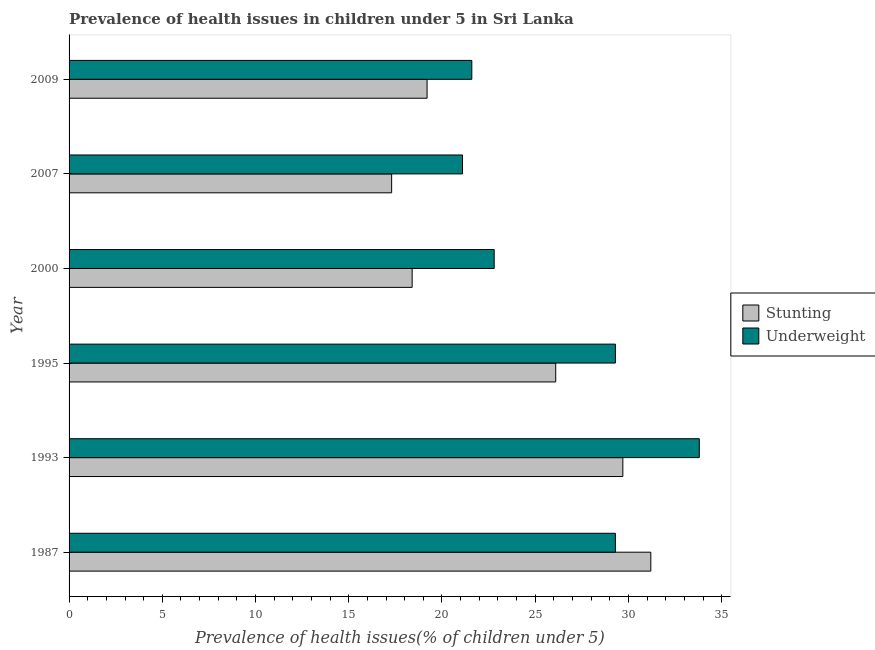How many different coloured bars are there?
Give a very brief answer. 2. How many groups of bars are there?
Ensure brevity in your answer.  6. Are the number of bars on each tick of the Y-axis equal?
Give a very brief answer. Yes. How many bars are there on the 1st tick from the bottom?
Offer a very short reply. 2. What is the label of the 3rd group of bars from the top?
Provide a succinct answer. 2000. In how many cases, is the number of bars for a given year not equal to the number of legend labels?
Make the answer very short. 0. What is the percentage of stunted children in 1993?
Offer a very short reply. 29.7. Across all years, what is the maximum percentage of stunted children?
Keep it short and to the point. 31.2. Across all years, what is the minimum percentage of underweight children?
Give a very brief answer. 21.1. What is the total percentage of stunted children in the graph?
Your answer should be very brief. 141.9. What is the difference between the percentage of underweight children in 2009 and the percentage of stunted children in 1987?
Offer a very short reply. -9.6. What is the average percentage of underweight children per year?
Offer a terse response. 26.32. What is the ratio of the percentage of stunted children in 1995 to that in 2009?
Give a very brief answer. 1.36. What is the difference between the highest and the second highest percentage of underweight children?
Provide a short and direct response. 4.5. What is the difference between the highest and the lowest percentage of underweight children?
Keep it short and to the point. 12.7. What does the 1st bar from the top in 2000 represents?
Your answer should be very brief. Underweight. What does the 1st bar from the bottom in 1987 represents?
Provide a short and direct response. Stunting. How many bars are there?
Ensure brevity in your answer.  12. What is the difference between two consecutive major ticks on the X-axis?
Offer a very short reply. 5. Are the values on the major ticks of X-axis written in scientific E-notation?
Your answer should be very brief. No. Does the graph contain grids?
Provide a short and direct response. No. What is the title of the graph?
Your answer should be very brief. Prevalence of health issues in children under 5 in Sri Lanka. Does "Number of arrivals" appear as one of the legend labels in the graph?
Provide a short and direct response. No. What is the label or title of the X-axis?
Give a very brief answer. Prevalence of health issues(% of children under 5). What is the Prevalence of health issues(% of children under 5) of Stunting in 1987?
Keep it short and to the point. 31.2. What is the Prevalence of health issues(% of children under 5) of Underweight in 1987?
Provide a short and direct response. 29.3. What is the Prevalence of health issues(% of children under 5) in Stunting in 1993?
Your answer should be very brief. 29.7. What is the Prevalence of health issues(% of children under 5) of Underweight in 1993?
Provide a short and direct response. 33.8. What is the Prevalence of health issues(% of children under 5) in Stunting in 1995?
Your response must be concise. 26.1. What is the Prevalence of health issues(% of children under 5) of Underweight in 1995?
Your answer should be compact. 29.3. What is the Prevalence of health issues(% of children under 5) of Stunting in 2000?
Make the answer very short. 18.4. What is the Prevalence of health issues(% of children under 5) in Underweight in 2000?
Your answer should be compact. 22.8. What is the Prevalence of health issues(% of children under 5) in Stunting in 2007?
Keep it short and to the point. 17.3. What is the Prevalence of health issues(% of children under 5) in Underweight in 2007?
Your response must be concise. 21.1. What is the Prevalence of health issues(% of children under 5) in Stunting in 2009?
Ensure brevity in your answer.  19.2. What is the Prevalence of health issues(% of children under 5) of Underweight in 2009?
Keep it short and to the point. 21.6. Across all years, what is the maximum Prevalence of health issues(% of children under 5) of Stunting?
Keep it short and to the point. 31.2. Across all years, what is the maximum Prevalence of health issues(% of children under 5) of Underweight?
Provide a short and direct response. 33.8. Across all years, what is the minimum Prevalence of health issues(% of children under 5) in Stunting?
Provide a short and direct response. 17.3. Across all years, what is the minimum Prevalence of health issues(% of children under 5) in Underweight?
Offer a terse response. 21.1. What is the total Prevalence of health issues(% of children under 5) of Stunting in the graph?
Make the answer very short. 141.9. What is the total Prevalence of health issues(% of children under 5) in Underweight in the graph?
Offer a very short reply. 157.9. What is the difference between the Prevalence of health issues(% of children under 5) in Stunting in 1987 and that in 1995?
Keep it short and to the point. 5.1. What is the difference between the Prevalence of health issues(% of children under 5) in Stunting in 1987 and that in 2000?
Keep it short and to the point. 12.8. What is the difference between the Prevalence of health issues(% of children under 5) in Underweight in 1987 and that in 2000?
Make the answer very short. 6.5. What is the difference between the Prevalence of health issues(% of children under 5) of Underweight in 1987 and that in 2007?
Your answer should be compact. 8.2. What is the difference between the Prevalence of health issues(% of children under 5) in Stunting in 1987 and that in 2009?
Your answer should be compact. 12. What is the difference between the Prevalence of health issues(% of children under 5) in Underweight in 1987 and that in 2009?
Your answer should be compact. 7.7. What is the difference between the Prevalence of health issues(% of children under 5) of Stunting in 1993 and that in 2000?
Provide a short and direct response. 11.3. What is the difference between the Prevalence of health issues(% of children under 5) of Stunting in 1993 and that in 2009?
Give a very brief answer. 10.5. What is the difference between the Prevalence of health issues(% of children under 5) of Underweight in 1993 and that in 2009?
Provide a succinct answer. 12.2. What is the difference between the Prevalence of health issues(% of children under 5) of Stunting in 1995 and that in 2000?
Your answer should be very brief. 7.7. What is the difference between the Prevalence of health issues(% of children under 5) in Underweight in 1995 and that in 2000?
Give a very brief answer. 6.5. What is the difference between the Prevalence of health issues(% of children under 5) of Underweight in 1995 and that in 2007?
Offer a terse response. 8.2. What is the difference between the Prevalence of health issues(% of children under 5) in Stunting in 1995 and that in 2009?
Your answer should be very brief. 6.9. What is the difference between the Prevalence of health issues(% of children under 5) in Underweight in 1995 and that in 2009?
Provide a succinct answer. 7.7. What is the difference between the Prevalence of health issues(% of children under 5) in Stunting in 2007 and that in 2009?
Offer a very short reply. -1.9. What is the difference between the Prevalence of health issues(% of children under 5) of Stunting in 1987 and the Prevalence of health issues(% of children under 5) of Underweight in 2007?
Your answer should be compact. 10.1. What is the difference between the Prevalence of health issues(% of children under 5) of Stunting in 1993 and the Prevalence of health issues(% of children under 5) of Underweight in 2000?
Ensure brevity in your answer.  6.9. What is the difference between the Prevalence of health issues(% of children under 5) in Stunting in 1993 and the Prevalence of health issues(% of children under 5) in Underweight in 2007?
Ensure brevity in your answer.  8.6. What is the difference between the Prevalence of health issues(% of children under 5) in Stunting in 1995 and the Prevalence of health issues(% of children under 5) in Underweight in 2000?
Ensure brevity in your answer.  3.3. What is the difference between the Prevalence of health issues(% of children under 5) of Stunting in 1995 and the Prevalence of health issues(% of children under 5) of Underweight in 2007?
Offer a terse response. 5. What is the difference between the Prevalence of health issues(% of children under 5) of Stunting in 2000 and the Prevalence of health issues(% of children under 5) of Underweight in 2007?
Provide a short and direct response. -2.7. What is the difference between the Prevalence of health issues(% of children under 5) of Stunting in 2007 and the Prevalence of health issues(% of children under 5) of Underweight in 2009?
Your response must be concise. -4.3. What is the average Prevalence of health issues(% of children under 5) of Stunting per year?
Offer a very short reply. 23.65. What is the average Prevalence of health issues(% of children under 5) of Underweight per year?
Provide a succinct answer. 26.32. In the year 1993, what is the difference between the Prevalence of health issues(% of children under 5) in Stunting and Prevalence of health issues(% of children under 5) in Underweight?
Provide a short and direct response. -4.1. In the year 1995, what is the difference between the Prevalence of health issues(% of children under 5) of Stunting and Prevalence of health issues(% of children under 5) of Underweight?
Keep it short and to the point. -3.2. In the year 2007, what is the difference between the Prevalence of health issues(% of children under 5) in Stunting and Prevalence of health issues(% of children under 5) in Underweight?
Ensure brevity in your answer.  -3.8. What is the ratio of the Prevalence of health issues(% of children under 5) of Stunting in 1987 to that in 1993?
Your answer should be very brief. 1.05. What is the ratio of the Prevalence of health issues(% of children under 5) in Underweight in 1987 to that in 1993?
Give a very brief answer. 0.87. What is the ratio of the Prevalence of health issues(% of children under 5) of Stunting in 1987 to that in 1995?
Your response must be concise. 1.2. What is the ratio of the Prevalence of health issues(% of children under 5) in Underweight in 1987 to that in 1995?
Make the answer very short. 1. What is the ratio of the Prevalence of health issues(% of children under 5) in Stunting in 1987 to that in 2000?
Your response must be concise. 1.7. What is the ratio of the Prevalence of health issues(% of children under 5) of Underweight in 1987 to that in 2000?
Ensure brevity in your answer.  1.29. What is the ratio of the Prevalence of health issues(% of children under 5) of Stunting in 1987 to that in 2007?
Offer a terse response. 1.8. What is the ratio of the Prevalence of health issues(% of children under 5) in Underweight in 1987 to that in 2007?
Provide a short and direct response. 1.39. What is the ratio of the Prevalence of health issues(% of children under 5) of Stunting in 1987 to that in 2009?
Offer a terse response. 1.62. What is the ratio of the Prevalence of health issues(% of children under 5) in Underweight in 1987 to that in 2009?
Give a very brief answer. 1.36. What is the ratio of the Prevalence of health issues(% of children under 5) in Stunting in 1993 to that in 1995?
Your answer should be very brief. 1.14. What is the ratio of the Prevalence of health issues(% of children under 5) of Underweight in 1993 to that in 1995?
Your answer should be compact. 1.15. What is the ratio of the Prevalence of health issues(% of children under 5) in Stunting in 1993 to that in 2000?
Ensure brevity in your answer.  1.61. What is the ratio of the Prevalence of health issues(% of children under 5) of Underweight in 1993 to that in 2000?
Ensure brevity in your answer.  1.48. What is the ratio of the Prevalence of health issues(% of children under 5) in Stunting in 1993 to that in 2007?
Keep it short and to the point. 1.72. What is the ratio of the Prevalence of health issues(% of children under 5) in Underweight in 1993 to that in 2007?
Make the answer very short. 1.6. What is the ratio of the Prevalence of health issues(% of children under 5) in Stunting in 1993 to that in 2009?
Provide a short and direct response. 1.55. What is the ratio of the Prevalence of health issues(% of children under 5) in Underweight in 1993 to that in 2009?
Ensure brevity in your answer.  1.56. What is the ratio of the Prevalence of health issues(% of children under 5) in Stunting in 1995 to that in 2000?
Offer a terse response. 1.42. What is the ratio of the Prevalence of health issues(% of children under 5) in Underweight in 1995 to that in 2000?
Give a very brief answer. 1.29. What is the ratio of the Prevalence of health issues(% of children under 5) of Stunting in 1995 to that in 2007?
Keep it short and to the point. 1.51. What is the ratio of the Prevalence of health issues(% of children under 5) in Underweight in 1995 to that in 2007?
Ensure brevity in your answer.  1.39. What is the ratio of the Prevalence of health issues(% of children under 5) of Stunting in 1995 to that in 2009?
Your answer should be compact. 1.36. What is the ratio of the Prevalence of health issues(% of children under 5) in Underweight in 1995 to that in 2009?
Offer a very short reply. 1.36. What is the ratio of the Prevalence of health issues(% of children under 5) of Stunting in 2000 to that in 2007?
Your response must be concise. 1.06. What is the ratio of the Prevalence of health issues(% of children under 5) in Underweight in 2000 to that in 2007?
Offer a terse response. 1.08. What is the ratio of the Prevalence of health issues(% of children under 5) of Underweight in 2000 to that in 2009?
Offer a very short reply. 1.06. What is the ratio of the Prevalence of health issues(% of children under 5) in Stunting in 2007 to that in 2009?
Your answer should be very brief. 0.9. What is the ratio of the Prevalence of health issues(% of children under 5) of Underweight in 2007 to that in 2009?
Give a very brief answer. 0.98. What is the difference between the highest and the second highest Prevalence of health issues(% of children under 5) of Stunting?
Keep it short and to the point. 1.5. What is the difference between the highest and the second highest Prevalence of health issues(% of children under 5) of Underweight?
Offer a terse response. 4.5. What is the difference between the highest and the lowest Prevalence of health issues(% of children under 5) of Stunting?
Offer a very short reply. 13.9. What is the difference between the highest and the lowest Prevalence of health issues(% of children under 5) of Underweight?
Offer a terse response. 12.7. 